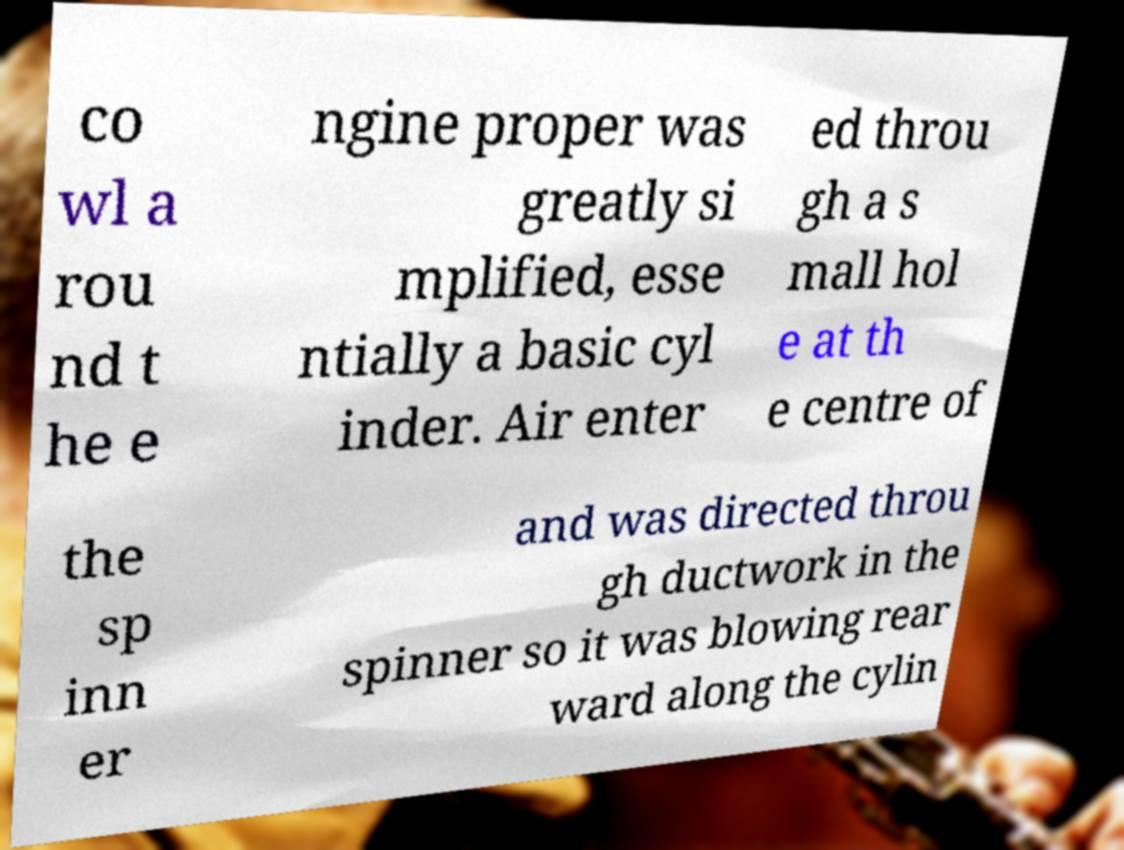For documentation purposes, I need the text within this image transcribed. Could you provide that? co wl a rou nd t he e ngine proper was greatly si mplified, esse ntially a basic cyl inder. Air enter ed throu gh a s mall hol e at th e centre of the sp inn er and was directed throu gh ductwork in the spinner so it was blowing rear ward along the cylin 